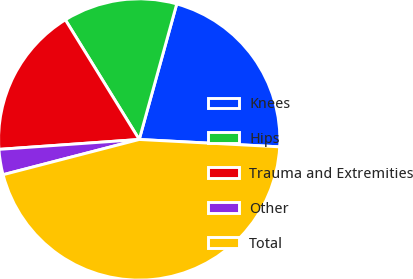<chart> <loc_0><loc_0><loc_500><loc_500><pie_chart><fcel>Knees<fcel>Hips<fcel>Trauma and Extremities<fcel>Other<fcel>Total<nl><fcel>21.54%<fcel>13.1%<fcel>17.32%<fcel>2.91%<fcel>45.14%<nl></chart> 